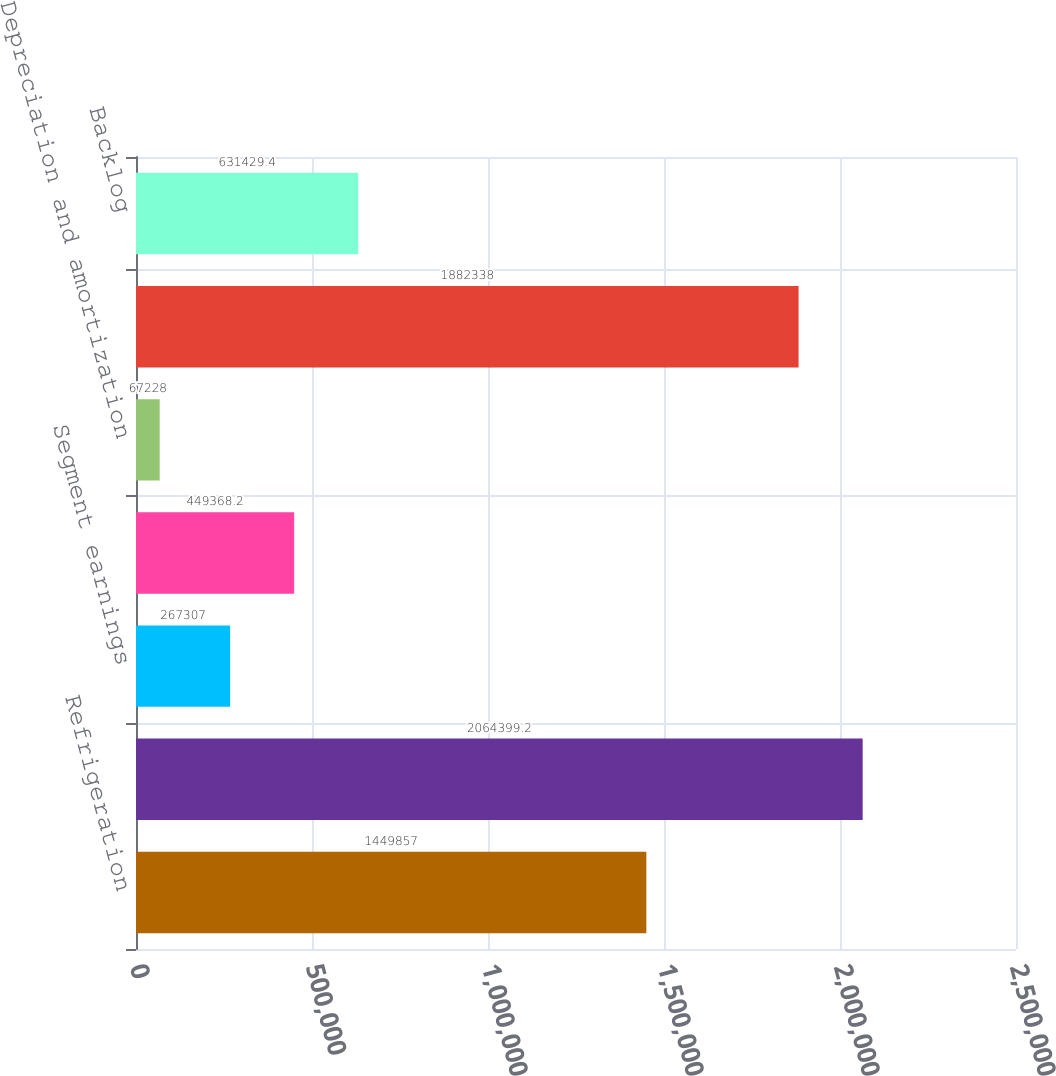<chart> <loc_0><loc_0><loc_500><loc_500><bar_chart><fcel>Refrigeration<fcel>Total<fcel>Segment earnings<fcel>Segment EBITDA<fcel>Depreciation and amortization<fcel>Bookings<fcel>Backlog<nl><fcel>1.44986e+06<fcel>2.0644e+06<fcel>267307<fcel>449368<fcel>67228<fcel>1.88234e+06<fcel>631429<nl></chart> 